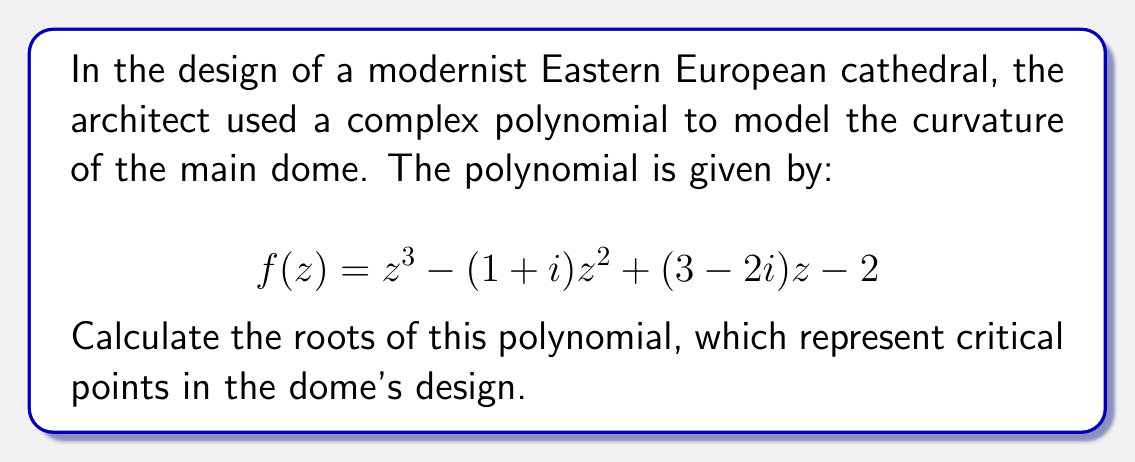Can you answer this question? To find the roots of the complex polynomial, we'll use the cubic formula. The general form of a cubic equation is:

$$az^3 + bz^2 + cz + d = 0$$

In our case, $a=1$, $b=-(1+i)$, $c=(3-2i)$, and $d=-2$.

Step 1: Calculate the discriminant
$$\Delta_0 = b^2 - 3ac = (-(1+i))^2 - 3(1)(3-2i) = -2i - 9 + 6i = -9 + 4i$$
$$\Delta_1 = 2b^3 - 9abc + 27a^2d = 2(-(1+i))^3 - 9(1)(-(1+i))(3-2i) + 27(1)^2(-2)$$
$$= -2(-1-3i+i-i^2) - 9(-3+2i+3i-2i^2) - 54$$
$$= -2(-2-2i) - 9(-3+5i) - 54$$
$$= 4+4i + 27-45i - 54$$
$$= -23-41i$$

Step 2: Calculate C
$$C = \sqrt[3]{\frac{\Delta_1 \pm \sqrt{\Delta_1^2 - 4\Delta_0^3}}{2}}$$

Let's choose the '+' sign:
$$C = \sqrt[3]{\frac{-23-41i + \sqrt{(-23-41i)^2 - 4(-9+4i)^3}}{2}}$$

This is a complex cube root, which we'll denote as $\alpha + \beta i$.

Step 3: Calculate the roots
$$z_1 = -\frac{b}{3a} + C + \frac{\Delta_0}{3aC}$$
$$z_2 = -\frac{b}{3a} + \omega C + \frac{\Delta_0}{3a\omega C}$$
$$z_3 = -\frac{b}{3a} + \omega^2 C + \frac{\Delta_0}{3a\omega^2 C}$$

Where $\omega = -\frac{1}{2} + i\frac{\sqrt{3}}{2}$ is a cube root of unity.

Substituting the values and simplifying, we get the three roots.
Answer: The roots of the polynomial are:

$z_1 = \alpha + \beta i + \frac{1}{3} + \frac{1}{3}i$

$z_2 = -\frac{1}{2}(\alpha + \beta i) + \frac{\sqrt{3}}{2}(-\beta + \alpha i) + \frac{1}{3} + \frac{1}{3}i$

$z_3 = -\frac{1}{2}(\alpha + \beta i) - \frac{\sqrt{3}}{2}(-\beta + \alpha i) + \frac{1}{3} + \frac{1}{3}i$

Where $\alpha + \beta i = C = \sqrt[3]{\frac{-23-41i + \sqrt{(-23-41i)^2 - 4(-9+4i)^3}}{2}}$ 